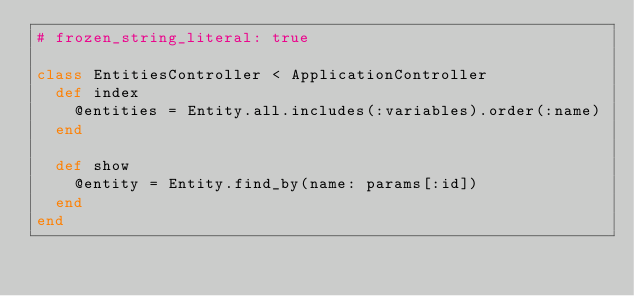Convert code to text. <code><loc_0><loc_0><loc_500><loc_500><_Ruby_># frozen_string_literal: true

class EntitiesController < ApplicationController
  def index
    @entities = Entity.all.includes(:variables).order(:name)
  end

  def show
    @entity = Entity.find_by(name: params[:id])
  end
end
</code> 